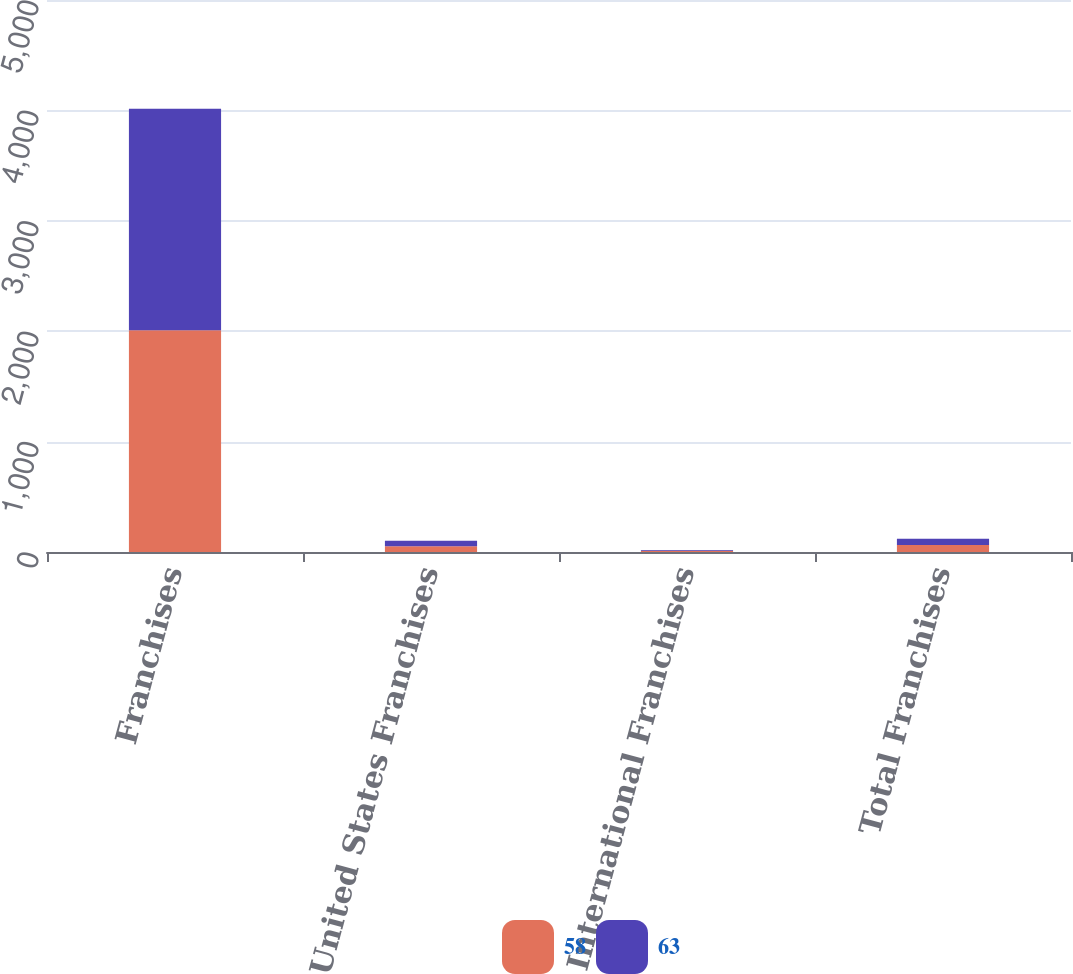<chart> <loc_0><loc_0><loc_500><loc_500><stacked_bar_chart><ecel><fcel>Franchises<fcel>United States Franchises<fcel>International Franchises<fcel>Total Franchises<nl><fcel>58<fcel>2008<fcel>52<fcel>11<fcel>63<nl><fcel>63<fcel>2007<fcel>51<fcel>7<fcel>58<nl></chart> 